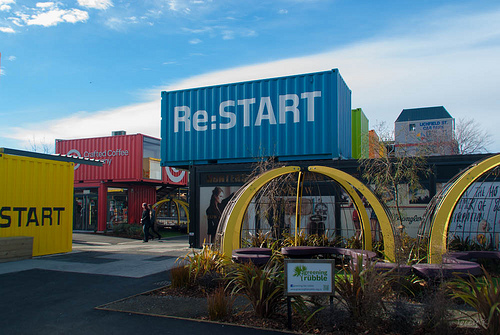<image>
Is there a target to the left of the shrub? Yes. From this viewpoint, the target is positioned to the left side relative to the shrub. 